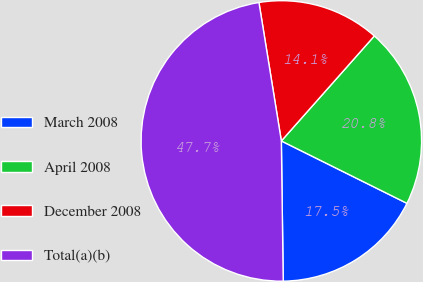Convert chart to OTSL. <chart><loc_0><loc_0><loc_500><loc_500><pie_chart><fcel>March 2008<fcel>April 2008<fcel>December 2008<fcel>Total(a)(b)<nl><fcel>17.45%<fcel>20.8%<fcel>14.09%<fcel>47.66%<nl></chart> 